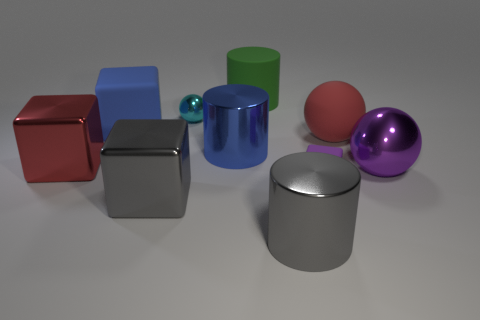Subtract all purple cylinders. Subtract all green blocks. How many cylinders are left? 3 Subtract all balls. How many objects are left? 7 Add 2 red metallic cubes. How many red metallic cubes are left? 3 Add 8 yellow metallic cubes. How many yellow metallic cubes exist? 8 Subtract 1 purple blocks. How many objects are left? 9 Subtract all yellow rubber things. Subtract all green rubber things. How many objects are left? 9 